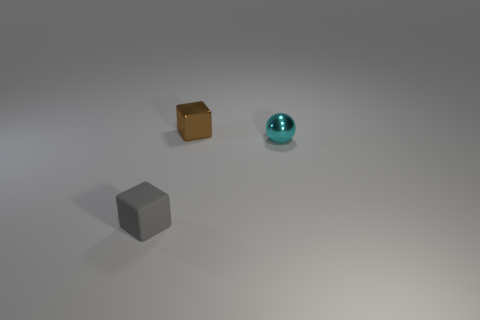Add 1 big purple metal cubes. How many objects exist? 4 Subtract 1 brown cubes. How many objects are left? 2 Subtract all cubes. How many objects are left? 1 Subtract 1 blocks. How many blocks are left? 1 Subtract all brown blocks. Subtract all yellow cylinders. How many blocks are left? 1 Subtract all cyan shiny objects. Subtract all gray things. How many objects are left? 1 Add 1 tiny metal balls. How many tiny metal balls are left? 2 Add 3 tiny matte things. How many tiny matte things exist? 4 